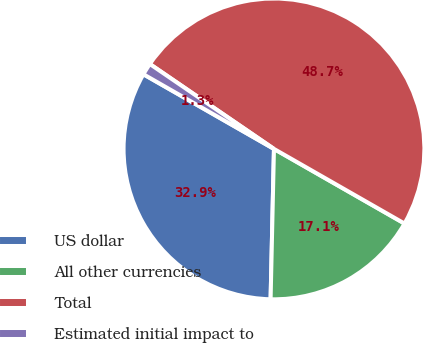<chart> <loc_0><loc_0><loc_500><loc_500><pie_chart><fcel>US dollar<fcel>All other currencies<fcel>Total<fcel>Estimated initial impact to<nl><fcel>32.91%<fcel>17.09%<fcel>48.72%<fcel>1.28%<nl></chart> 